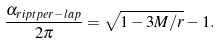Convert formula to latex. <formula><loc_0><loc_0><loc_500><loc_500>\frac { \alpha _ { r i p t { p e r - l a p } } } { 2 \pi } = \sqrt { 1 - 3 M / r } - 1 .</formula> 